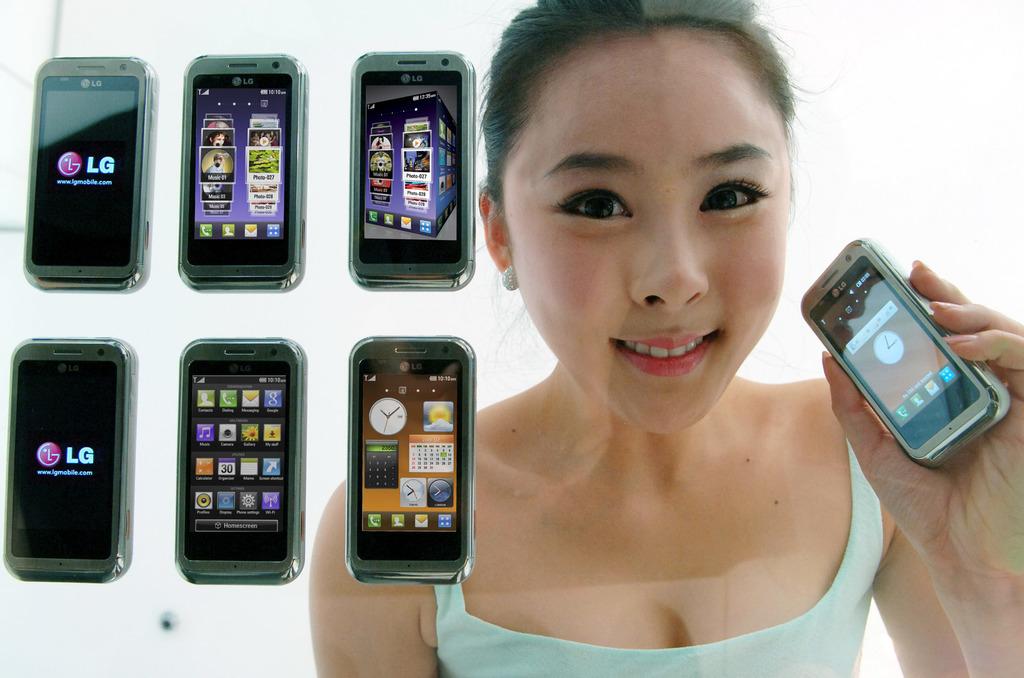What brand is the phone?
Keep it short and to the point. Lg. What kind of phone is being shown here?
Offer a terse response. Lg. 